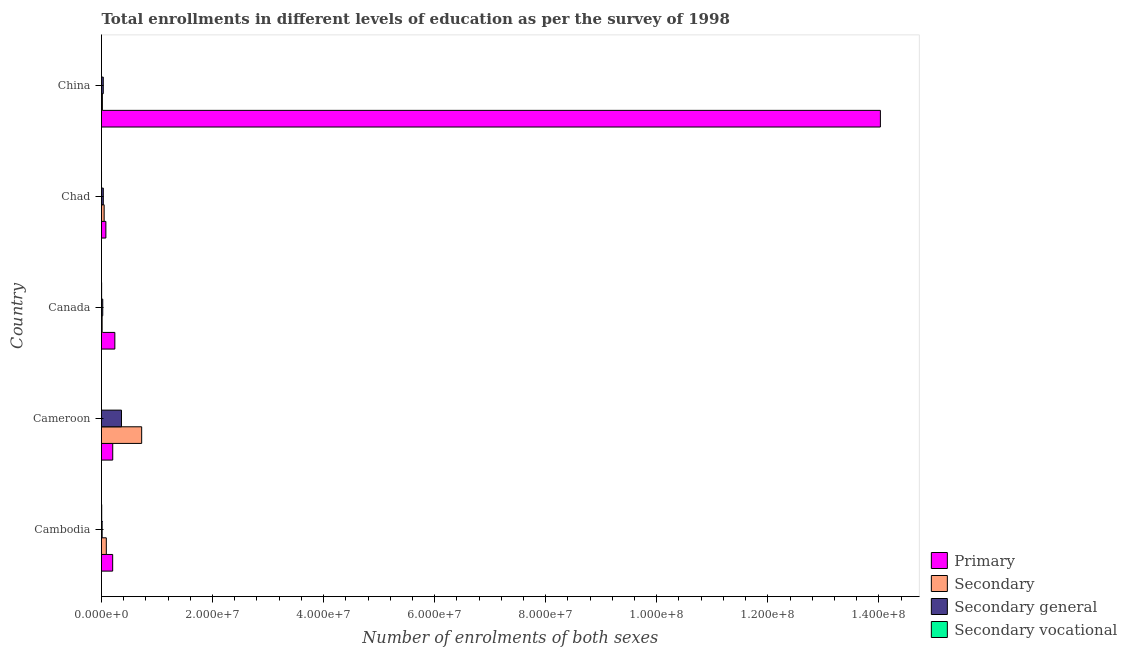How many bars are there on the 4th tick from the top?
Ensure brevity in your answer.  4. How many bars are there on the 5th tick from the bottom?
Offer a very short reply. 4. What is the number of enrolments in secondary vocational education in Cambodia?
Make the answer very short. 3.82e+04. Across all countries, what is the maximum number of enrolments in secondary general education?
Your answer should be compact. 3.60e+06. Across all countries, what is the minimum number of enrolments in secondary education?
Ensure brevity in your answer.  1.16e+05. In which country was the number of enrolments in secondary general education minimum?
Ensure brevity in your answer.  Cambodia. What is the total number of enrolments in secondary vocational education in the graph?
Keep it short and to the point. 6.26e+04. What is the difference between the number of enrolments in secondary general education in Cameroon and that in China?
Offer a very short reply. 3.28e+06. What is the difference between the number of enrolments in primary education in Chad and the number of enrolments in secondary general education in Cambodia?
Provide a succinct answer. 6.71e+05. What is the average number of enrolments in secondary vocational education per country?
Make the answer very short. 1.25e+04. What is the difference between the number of enrolments in primary education and number of enrolments in secondary general education in Canada?
Offer a terse response. 2.18e+06. In how many countries, is the number of enrolments in secondary vocational education greater than 104000000 ?
Offer a terse response. 0. What is the ratio of the number of enrolments in secondary general education in Cambodia to that in Chad?
Make the answer very short. 0.36. Is the difference between the number of enrolments in primary education in Canada and Chad greater than the difference between the number of enrolments in secondary vocational education in Canada and Chad?
Make the answer very short. Yes. What is the difference between the highest and the second highest number of enrolments in primary education?
Your answer should be very brief. 1.38e+08. What is the difference between the highest and the lowest number of enrolments in secondary general education?
Your answer should be compact. 3.48e+06. In how many countries, is the number of enrolments in secondary general education greater than the average number of enrolments in secondary general education taken over all countries?
Give a very brief answer. 1. What does the 4th bar from the top in Cambodia represents?
Keep it short and to the point. Primary. What does the 1st bar from the bottom in Canada represents?
Provide a succinct answer. Primary. Are the values on the major ticks of X-axis written in scientific E-notation?
Offer a terse response. Yes. Does the graph contain any zero values?
Your response must be concise. No. Where does the legend appear in the graph?
Provide a short and direct response. Bottom right. How many legend labels are there?
Ensure brevity in your answer.  4. What is the title of the graph?
Keep it short and to the point. Total enrollments in different levels of education as per the survey of 1998. What is the label or title of the X-axis?
Give a very brief answer. Number of enrolments of both sexes. What is the Number of enrolments of both sexes in Primary in Cambodia?
Provide a succinct answer. 2.01e+06. What is the Number of enrolments of both sexes in Secondary in Cambodia?
Make the answer very short. 8.67e+05. What is the Number of enrolments of both sexes in Secondary general in Cambodia?
Your response must be concise. 1.15e+05. What is the Number of enrolments of both sexes of Secondary vocational in Cambodia?
Keep it short and to the point. 3.82e+04. What is the Number of enrolments of both sexes in Primary in Cameroon?
Offer a terse response. 2.02e+06. What is the Number of enrolments of both sexes of Secondary in Cameroon?
Give a very brief answer. 7.23e+06. What is the Number of enrolments of both sexes in Secondary general in Cameroon?
Make the answer very short. 3.60e+06. What is the Number of enrolments of both sexes in Secondary vocational in Cameroon?
Make the answer very short. 655. What is the Number of enrolments of both sexes of Primary in Canada?
Give a very brief answer. 2.40e+06. What is the Number of enrolments of both sexes in Secondary in Canada?
Provide a short and direct response. 1.16e+05. What is the Number of enrolments of both sexes of Secondary general in Canada?
Keep it short and to the point. 2.23e+05. What is the Number of enrolments of both sexes of Secondary vocational in Canada?
Provide a short and direct response. 2.17e+04. What is the Number of enrolments of both sexes of Primary in Chad?
Keep it short and to the point. 7.87e+05. What is the Number of enrolments of both sexes of Secondary in Chad?
Keep it short and to the point. 4.78e+05. What is the Number of enrolments of both sexes in Secondary general in Chad?
Offer a terse response. 3.22e+05. What is the Number of enrolments of both sexes of Secondary vocational in Chad?
Offer a terse response. 1911. What is the Number of enrolments of both sexes in Primary in China?
Your answer should be very brief. 1.40e+08. What is the Number of enrolments of both sexes of Secondary in China?
Your answer should be compact. 1.60e+05. What is the Number of enrolments of both sexes of Secondary general in China?
Your response must be concise. 3.18e+05. What is the Number of enrolments of both sexes of Secondary vocational in China?
Ensure brevity in your answer.  90. Across all countries, what is the maximum Number of enrolments of both sexes of Primary?
Give a very brief answer. 1.40e+08. Across all countries, what is the maximum Number of enrolments of both sexes of Secondary?
Give a very brief answer. 7.23e+06. Across all countries, what is the maximum Number of enrolments of both sexes of Secondary general?
Your response must be concise. 3.60e+06. Across all countries, what is the maximum Number of enrolments of both sexes in Secondary vocational?
Ensure brevity in your answer.  3.82e+04. Across all countries, what is the minimum Number of enrolments of both sexes of Primary?
Make the answer very short. 7.87e+05. Across all countries, what is the minimum Number of enrolments of both sexes of Secondary?
Offer a terse response. 1.16e+05. Across all countries, what is the minimum Number of enrolments of both sexes in Secondary general?
Your answer should be very brief. 1.15e+05. What is the total Number of enrolments of both sexes of Primary in the graph?
Keep it short and to the point. 1.47e+08. What is the total Number of enrolments of both sexes in Secondary in the graph?
Your response must be concise. 8.85e+06. What is the total Number of enrolments of both sexes of Secondary general in the graph?
Keep it short and to the point. 4.58e+06. What is the total Number of enrolments of both sexes in Secondary vocational in the graph?
Give a very brief answer. 6.26e+04. What is the difference between the Number of enrolments of both sexes in Primary in Cambodia and that in Cameroon?
Offer a very short reply. -1.20e+04. What is the difference between the Number of enrolments of both sexes of Secondary in Cambodia and that in Cameroon?
Provide a succinct answer. -6.37e+06. What is the difference between the Number of enrolments of both sexes in Secondary general in Cambodia and that in Cameroon?
Make the answer very short. -3.48e+06. What is the difference between the Number of enrolments of both sexes in Secondary vocational in Cambodia and that in Cameroon?
Your response must be concise. 3.76e+04. What is the difference between the Number of enrolments of both sexes in Primary in Cambodia and that in Canada?
Ensure brevity in your answer.  -3.90e+05. What is the difference between the Number of enrolments of both sexes of Secondary in Cambodia and that in Canada?
Keep it short and to the point. 7.51e+05. What is the difference between the Number of enrolments of both sexes in Secondary general in Cambodia and that in Canada?
Provide a succinct answer. -1.08e+05. What is the difference between the Number of enrolments of both sexes in Secondary vocational in Cambodia and that in Canada?
Provide a succinct answer. 1.65e+04. What is the difference between the Number of enrolments of both sexes of Primary in Cambodia and that in Chad?
Make the answer very short. 1.23e+06. What is the difference between the Number of enrolments of both sexes of Secondary in Cambodia and that in Chad?
Give a very brief answer. 3.89e+05. What is the difference between the Number of enrolments of both sexes in Secondary general in Cambodia and that in Chad?
Your response must be concise. -2.07e+05. What is the difference between the Number of enrolments of both sexes in Secondary vocational in Cambodia and that in Chad?
Provide a short and direct response. 3.63e+04. What is the difference between the Number of enrolments of both sexes of Primary in Cambodia and that in China?
Ensure brevity in your answer.  -1.38e+08. What is the difference between the Number of enrolments of both sexes in Secondary in Cambodia and that in China?
Provide a succinct answer. 7.07e+05. What is the difference between the Number of enrolments of both sexes of Secondary general in Cambodia and that in China?
Provide a short and direct response. -2.03e+05. What is the difference between the Number of enrolments of both sexes in Secondary vocational in Cambodia and that in China?
Offer a terse response. 3.81e+04. What is the difference between the Number of enrolments of both sexes of Primary in Cameroon and that in Canada?
Offer a very short reply. -3.78e+05. What is the difference between the Number of enrolments of both sexes in Secondary in Cameroon and that in Canada?
Provide a succinct answer. 7.12e+06. What is the difference between the Number of enrolments of both sexes in Secondary general in Cameroon and that in Canada?
Provide a short and direct response. 3.37e+06. What is the difference between the Number of enrolments of both sexes of Secondary vocational in Cameroon and that in Canada?
Your answer should be very brief. -2.11e+04. What is the difference between the Number of enrolments of both sexes in Primary in Cameroon and that in Chad?
Your response must be concise. 1.24e+06. What is the difference between the Number of enrolments of both sexes of Secondary in Cameroon and that in Chad?
Your answer should be compact. 6.76e+06. What is the difference between the Number of enrolments of both sexes in Secondary general in Cameroon and that in Chad?
Give a very brief answer. 3.28e+06. What is the difference between the Number of enrolments of both sexes of Secondary vocational in Cameroon and that in Chad?
Offer a terse response. -1256. What is the difference between the Number of enrolments of both sexes in Primary in Cameroon and that in China?
Give a very brief answer. -1.38e+08. What is the difference between the Number of enrolments of both sexes of Secondary in Cameroon and that in China?
Provide a succinct answer. 7.07e+06. What is the difference between the Number of enrolments of both sexes of Secondary general in Cameroon and that in China?
Give a very brief answer. 3.28e+06. What is the difference between the Number of enrolments of both sexes in Secondary vocational in Cameroon and that in China?
Keep it short and to the point. 565. What is the difference between the Number of enrolments of both sexes in Primary in Canada and that in Chad?
Give a very brief answer. 1.62e+06. What is the difference between the Number of enrolments of both sexes of Secondary in Canada and that in Chad?
Offer a very short reply. -3.62e+05. What is the difference between the Number of enrolments of both sexes of Secondary general in Canada and that in Chad?
Your answer should be compact. -9.93e+04. What is the difference between the Number of enrolments of both sexes in Secondary vocational in Canada and that in Chad?
Your response must be concise. 1.98e+04. What is the difference between the Number of enrolments of both sexes in Primary in Canada and that in China?
Ensure brevity in your answer.  -1.38e+08. What is the difference between the Number of enrolments of both sexes of Secondary in Canada and that in China?
Offer a very short reply. -4.44e+04. What is the difference between the Number of enrolments of both sexes of Secondary general in Canada and that in China?
Offer a terse response. -9.53e+04. What is the difference between the Number of enrolments of both sexes of Secondary vocational in Canada and that in China?
Provide a succinct answer. 2.16e+04. What is the difference between the Number of enrolments of both sexes of Primary in Chad and that in China?
Your answer should be very brief. -1.39e+08. What is the difference between the Number of enrolments of both sexes of Secondary in Chad and that in China?
Offer a terse response. 3.18e+05. What is the difference between the Number of enrolments of both sexes in Secondary general in Chad and that in China?
Your answer should be compact. 4019. What is the difference between the Number of enrolments of both sexes of Secondary vocational in Chad and that in China?
Your answer should be very brief. 1821. What is the difference between the Number of enrolments of both sexes in Primary in Cambodia and the Number of enrolments of both sexes in Secondary in Cameroon?
Make the answer very short. -5.22e+06. What is the difference between the Number of enrolments of both sexes in Primary in Cambodia and the Number of enrolments of both sexes in Secondary general in Cameroon?
Ensure brevity in your answer.  -1.59e+06. What is the difference between the Number of enrolments of both sexes in Primary in Cambodia and the Number of enrolments of both sexes in Secondary vocational in Cameroon?
Your answer should be very brief. 2.01e+06. What is the difference between the Number of enrolments of both sexes of Secondary in Cambodia and the Number of enrolments of both sexes of Secondary general in Cameroon?
Keep it short and to the point. -2.73e+06. What is the difference between the Number of enrolments of both sexes of Secondary in Cambodia and the Number of enrolments of both sexes of Secondary vocational in Cameroon?
Provide a succinct answer. 8.66e+05. What is the difference between the Number of enrolments of both sexes of Secondary general in Cambodia and the Number of enrolments of both sexes of Secondary vocational in Cameroon?
Your response must be concise. 1.15e+05. What is the difference between the Number of enrolments of both sexes in Primary in Cambodia and the Number of enrolments of both sexes in Secondary in Canada?
Ensure brevity in your answer.  1.90e+06. What is the difference between the Number of enrolments of both sexes of Primary in Cambodia and the Number of enrolments of both sexes of Secondary general in Canada?
Provide a succinct answer. 1.79e+06. What is the difference between the Number of enrolments of both sexes in Primary in Cambodia and the Number of enrolments of both sexes in Secondary vocational in Canada?
Ensure brevity in your answer.  1.99e+06. What is the difference between the Number of enrolments of both sexes in Secondary in Cambodia and the Number of enrolments of both sexes in Secondary general in Canada?
Make the answer very short. 6.44e+05. What is the difference between the Number of enrolments of both sexes in Secondary in Cambodia and the Number of enrolments of both sexes in Secondary vocational in Canada?
Offer a very short reply. 8.45e+05. What is the difference between the Number of enrolments of both sexes in Secondary general in Cambodia and the Number of enrolments of both sexes in Secondary vocational in Canada?
Ensure brevity in your answer.  9.36e+04. What is the difference between the Number of enrolments of both sexes in Primary in Cambodia and the Number of enrolments of both sexes in Secondary in Chad?
Provide a succinct answer. 1.53e+06. What is the difference between the Number of enrolments of both sexes of Primary in Cambodia and the Number of enrolments of both sexes of Secondary general in Chad?
Your answer should be very brief. 1.69e+06. What is the difference between the Number of enrolments of both sexes of Primary in Cambodia and the Number of enrolments of both sexes of Secondary vocational in Chad?
Keep it short and to the point. 2.01e+06. What is the difference between the Number of enrolments of both sexes in Secondary in Cambodia and the Number of enrolments of both sexes in Secondary general in Chad?
Offer a terse response. 5.44e+05. What is the difference between the Number of enrolments of both sexes of Secondary in Cambodia and the Number of enrolments of both sexes of Secondary vocational in Chad?
Ensure brevity in your answer.  8.65e+05. What is the difference between the Number of enrolments of both sexes of Secondary general in Cambodia and the Number of enrolments of both sexes of Secondary vocational in Chad?
Give a very brief answer. 1.13e+05. What is the difference between the Number of enrolments of both sexes of Primary in Cambodia and the Number of enrolments of both sexes of Secondary in China?
Your answer should be compact. 1.85e+06. What is the difference between the Number of enrolments of both sexes of Primary in Cambodia and the Number of enrolments of both sexes of Secondary general in China?
Make the answer very short. 1.69e+06. What is the difference between the Number of enrolments of both sexes of Primary in Cambodia and the Number of enrolments of both sexes of Secondary vocational in China?
Keep it short and to the point. 2.01e+06. What is the difference between the Number of enrolments of both sexes of Secondary in Cambodia and the Number of enrolments of both sexes of Secondary general in China?
Offer a very short reply. 5.48e+05. What is the difference between the Number of enrolments of both sexes of Secondary in Cambodia and the Number of enrolments of both sexes of Secondary vocational in China?
Offer a very short reply. 8.67e+05. What is the difference between the Number of enrolments of both sexes of Secondary general in Cambodia and the Number of enrolments of both sexes of Secondary vocational in China?
Offer a very short reply. 1.15e+05. What is the difference between the Number of enrolments of both sexes in Primary in Cameroon and the Number of enrolments of both sexes in Secondary in Canada?
Your response must be concise. 1.91e+06. What is the difference between the Number of enrolments of both sexes in Primary in Cameroon and the Number of enrolments of both sexes in Secondary general in Canada?
Your answer should be very brief. 1.80e+06. What is the difference between the Number of enrolments of both sexes in Primary in Cameroon and the Number of enrolments of both sexes in Secondary vocational in Canada?
Your answer should be very brief. 2.00e+06. What is the difference between the Number of enrolments of both sexes in Secondary in Cameroon and the Number of enrolments of both sexes in Secondary general in Canada?
Make the answer very short. 7.01e+06. What is the difference between the Number of enrolments of both sexes of Secondary in Cameroon and the Number of enrolments of both sexes of Secondary vocational in Canada?
Make the answer very short. 7.21e+06. What is the difference between the Number of enrolments of both sexes of Secondary general in Cameroon and the Number of enrolments of both sexes of Secondary vocational in Canada?
Give a very brief answer. 3.58e+06. What is the difference between the Number of enrolments of both sexes of Primary in Cameroon and the Number of enrolments of both sexes of Secondary in Chad?
Your answer should be very brief. 1.55e+06. What is the difference between the Number of enrolments of both sexes of Primary in Cameroon and the Number of enrolments of both sexes of Secondary general in Chad?
Keep it short and to the point. 1.70e+06. What is the difference between the Number of enrolments of both sexes in Primary in Cameroon and the Number of enrolments of both sexes in Secondary vocational in Chad?
Your answer should be very brief. 2.02e+06. What is the difference between the Number of enrolments of both sexes of Secondary in Cameroon and the Number of enrolments of both sexes of Secondary general in Chad?
Provide a succinct answer. 6.91e+06. What is the difference between the Number of enrolments of both sexes in Secondary in Cameroon and the Number of enrolments of both sexes in Secondary vocational in Chad?
Give a very brief answer. 7.23e+06. What is the difference between the Number of enrolments of both sexes of Secondary general in Cameroon and the Number of enrolments of both sexes of Secondary vocational in Chad?
Offer a very short reply. 3.60e+06. What is the difference between the Number of enrolments of both sexes of Primary in Cameroon and the Number of enrolments of both sexes of Secondary in China?
Your response must be concise. 1.86e+06. What is the difference between the Number of enrolments of both sexes in Primary in Cameroon and the Number of enrolments of both sexes in Secondary general in China?
Make the answer very short. 1.71e+06. What is the difference between the Number of enrolments of both sexes of Primary in Cameroon and the Number of enrolments of both sexes of Secondary vocational in China?
Ensure brevity in your answer.  2.02e+06. What is the difference between the Number of enrolments of both sexes of Secondary in Cameroon and the Number of enrolments of both sexes of Secondary general in China?
Your answer should be compact. 6.91e+06. What is the difference between the Number of enrolments of both sexes in Secondary in Cameroon and the Number of enrolments of both sexes in Secondary vocational in China?
Your answer should be compact. 7.23e+06. What is the difference between the Number of enrolments of both sexes in Secondary general in Cameroon and the Number of enrolments of both sexes in Secondary vocational in China?
Provide a short and direct response. 3.60e+06. What is the difference between the Number of enrolments of both sexes in Primary in Canada and the Number of enrolments of both sexes in Secondary in Chad?
Your answer should be very brief. 1.92e+06. What is the difference between the Number of enrolments of both sexes of Primary in Canada and the Number of enrolments of both sexes of Secondary general in Chad?
Make the answer very short. 2.08e+06. What is the difference between the Number of enrolments of both sexes in Primary in Canada and the Number of enrolments of both sexes in Secondary vocational in Chad?
Offer a terse response. 2.40e+06. What is the difference between the Number of enrolments of both sexes of Secondary in Canada and the Number of enrolments of both sexes of Secondary general in Chad?
Make the answer very short. -2.07e+05. What is the difference between the Number of enrolments of both sexes of Secondary in Canada and the Number of enrolments of both sexes of Secondary vocational in Chad?
Your answer should be compact. 1.14e+05. What is the difference between the Number of enrolments of both sexes in Secondary general in Canada and the Number of enrolments of both sexes in Secondary vocational in Chad?
Keep it short and to the point. 2.21e+05. What is the difference between the Number of enrolments of both sexes in Primary in Canada and the Number of enrolments of both sexes in Secondary in China?
Ensure brevity in your answer.  2.24e+06. What is the difference between the Number of enrolments of both sexes of Primary in Canada and the Number of enrolments of both sexes of Secondary general in China?
Your answer should be compact. 2.08e+06. What is the difference between the Number of enrolments of both sexes in Primary in Canada and the Number of enrolments of both sexes in Secondary vocational in China?
Give a very brief answer. 2.40e+06. What is the difference between the Number of enrolments of both sexes in Secondary in Canada and the Number of enrolments of both sexes in Secondary general in China?
Your answer should be compact. -2.03e+05. What is the difference between the Number of enrolments of both sexes in Secondary in Canada and the Number of enrolments of both sexes in Secondary vocational in China?
Offer a very short reply. 1.16e+05. What is the difference between the Number of enrolments of both sexes in Secondary general in Canada and the Number of enrolments of both sexes in Secondary vocational in China?
Ensure brevity in your answer.  2.23e+05. What is the difference between the Number of enrolments of both sexes in Primary in Chad and the Number of enrolments of both sexes in Secondary in China?
Keep it short and to the point. 6.26e+05. What is the difference between the Number of enrolments of both sexes in Primary in Chad and the Number of enrolments of both sexes in Secondary general in China?
Give a very brief answer. 4.68e+05. What is the difference between the Number of enrolments of both sexes in Primary in Chad and the Number of enrolments of both sexes in Secondary vocational in China?
Ensure brevity in your answer.  7.86e+05. What is the difference between the Number of enrolments of both sexes in Secondary in Chad and the Number of enrolments of both sexes in Secondary general in China?
Give a very brief answer. 1.60e+05. What is the difference between the Number of enrolments of both sexes of Secondary in Chad and the Number of enrolments of both sexes of Secondary vocational in China?
Provide a short and direct response. 4.78e+05. What is the difference between the Number of enrolments of both sexes of Secondary general in Chad and the Number of enrolments of both sexes of Secondary vocational in China?
Provide a short and direct response. 3.22e+05. What is the average Number of enrolments of both sexes of Primary per country?
Your answer should be very brief. 2.95e+07. What is the average Number of enrolments of both sexes of Secondary per country?
Your response must be concise. 1.77e+06. What is the average Number of enrolments of both sexes in Secondary general per country?
Give a very brief answer. 9.15e+05. What is the average Number of enrolments of both sexes of Secondary vocational per country?
Your answer should be very brief. 1.25e+04. What is the difference between the Number of enrolments of both sexes of Primary and Number of enrolments of both sexes of Secondary in Cambodia?
Your answer should be very brief. 1.15e+06. What is the difference between the Number of enrolments of both sexes of Primary and Number of enrolments of both sexes of Secondary general in Cambodia?
Your answer should be very brief. 1.90e+06. What is the difference between the Number of enrolments of both sexes in Primary and Number of enrolments of both sexes in Secondary vocational in Cambodia?
Your answer should be very brief. 1.97e+06. What is the difference between the Number of enrolments of both sexes of Secondary and Number of enrolments of both sexes of Secondary general in Cambodia?
Ensure brevity in your answer.  7.51e+05. What is the difference between the Number of enrolments of both sexes of Secondary and Number of enrolments of both sexes of Secondary vocational in Cambodia?
Your answer should be very brief. 8.28e+05. What is the difference between the Number of enrolments of both sexes in Secondary general and Number of enrolments of both sexes in Secondary vocational in Cambodia?
Ensure brevity in your answer.  7.71e+04. What is the difference between the Number of enrolments of both sexes of Primary and Number of enrolments of both sexes of Secondary in Cameroon?
Give a very brief answer. -5.21e+06. What is the difference between the Number of enrolments of both sexes in Primary and Number of enrolments of both sexes in Secondary general in Cameroon?
Your answer should be compact. -1.57e+06. What is the difference between the Number of enrolments of both sexes of Primary and Number of enrolments of both sexes of Secondary vocational in Cameroon?
Offer a terse response. 2.02e+06. What is the difference between the Number of enrolments of both sexes in Secondary and Number of enrolments of both sexes in Secondary general in Cameroon?
Offer a terse response. 3.64e+06. What is the difference between the Number of enrolments of both sexes of Secondary and Number of enrolments of both sexes of Secondary vocational in Cameroon?
Make the answer very short. 7.23e+06. What is the difference between the Number of enrolments of both sexes of Secondary general and Number of enrolments of both sexes of Secondary vocational in Cameroon?
Offer a terse response. 3.60e+06. What is the difference between the Number of enrolments of both sexes of Primary and Number of enrolments of both sexes of Secondary in Canada?
Give a very brief answer. 2.29e+06. What is the difference between the Number of enrolments of both sexes of Primary and Number of enrolments of both sexes of Secondary general in Canada?
Offer a terse response. 2.18e+06. What is the difference between the Number of enrolments of both sexes in Primary and Number of enrolments of both sexes in Secondary vocational in Canada?
Your answer should be very brief. 2.38e+06. What is the difference between the Number of enrolments of both sexes in Secondary and Number of enrolments of both sexes in Secondary general in Canada?
Ensure brevity in your answer.  -1.07e+05. What is the difference between the Number of enrolments of both sexes in Secondary and Number of enrolments of both sexes in Secondary vocational in Canada?
Your answer should be compact. 9.39e+04. What is the difference between the Number of enrolments of both sexes of Secondary general and Number of enrolments of both sexes of Secondary vocational in Canada?
Give a very brief answer. 2.01e+05. What is the difference between the Number of enrolments of both sexes of Primary and Number of enrolments of both sexes of Secondary in Chad?
Offer a very short reply. 3.09e+05. What is the difference between the Number of enrolments of both sexes of Primary and Number of enrolments of both sexes of Secondary general in Chad?
Offer a very short reply. 4.64e+05. What is the difference between the Number of enrolments of both sexes of Primary and Number of enrolments of both sexes of Secondary vocational in Chad?
Your answer should be compact. 7.85e+05. What is the difference between the Number of enrolments of both sexes in Secondary and Number of enrolments of both sexes in Secondary general in Chad?
Give a very brief answer. 1.56e+05. What is the difference between the Number of enrolments of both sexes in Secondary and Number of enrolments of both sexes in Secondary vocational in Chad?
Give a very brief answer. 4.76e+05. What is the difference between the Number of enrolments of both sexes in Secondary general and Number of enrolments of both sexes in Secondary vocational in Chad?
Give a very brief answer. 3.20e+05. What is the difference between the Number of enrolments of both sexes in Primary and Number of enrolments of both sexes in Secondary in China?
Offer a very short reply. 1.40e+08. What is the difference between the Number of enrolments of both sexes in Primary and Number of enrolments of both sexes in Secondary general in China?
Your response must be concise. 1.40e+08. What is the difference between the Number of enrolments of both sexes of Primary and Number of enrolments of both sexes of Secondary vocational in China?
Your response must be concise. 1.40e+08. What is the difference between the Number of enrolments of both sexes of Secondary and Number of enrolments of both sexes of Secondary general in China?
Provide a succinct answer. -1.58e+05. What is the difference between the Number of enrolments of both sexes of Secondary and Number of enrolments of both sexes of Secondary vocational in China?
Make the answer very short. 1.60e+05. What is the difference between the Number of enrolments of both sexes in Secondary general and Number of enrolments of both sexes in Secondary vocational in China?
Your answer should be compact. 3.18e+05. What is the ratio of the Number of enrolments of both sexes in Primary in Cambodia to that in Cameroon?
Make the answer very short. 0.99. What is the ratio of the Number of enrolments of both sexes of Secondary in Cambodia to that in Cameroon?
Provide a short and direct response. 0.12. What is the ratio of the Number of enrolments of both sexes in Secondary general in Cambodia to that in Cameroon?
Offer a very short reply. 0.03. What is the ratio of the Number of enrolments of both sexes of Secondary vocational in Cambodia to that in Cameroon?
Provide a succinct answer. 58.38. What is the ratio of the Number of enrolments of both sexes in Primary in Cambodia to that in Canada?
Ensure brevity in your answer.  0.84. What is the ratio of the Number of enrolments of both sexes of Secondary in Cambodia to that in Canada?
Your response must be concise. 7.5. What is the ratio of the Number of enrolments of both sexes in Secondary general in Cambodia to that in Canada?
Give a very brief answer. 0.52. What is the ratio of the Number of enrolments of both sexes of Secondary vocational in Cambodia to that in Canada?
Offer a very short reply. 1.76. What is the ratio of the Number of enrolments of both sexes in Primary in Cambodia to that in Chad?
Provide a short and direct response. 2.56. What is the ratio of the Number of enrolments of both sexes in Secondary in Cambodia to that in Chad?
Offer a terse response. 1.81. What is the ratio of the Number of enrolments of both sexes of Secondary general in Cambodia to that in Chad?
Provide a succinct answer. 0.36. What is the ratio of the Number of enrolments of both sexes of Secondary vocational in Cambodia to that in Chad?
Ensure brevity in your answer.  20.01. What is the ratio of the Number of enrolments of both sexes in Primary in Cambodia to that in China?
Keep it short and to the point. 0.01. What is the ratio of the Number of enrolments of both sexes of Secondary in Cambodia to that in China?
Provide a short and direct response. 5.41. What is the ratio of the Number of enrolments of both sexes in Secondary general in Cambodia to that in China?
Offer a very short reply. 0.36. What is the ratio of the Number of enrolments of both sexes in Secondary vocational in Cambodia to that in China?
Your answer should be very brief. 424.86. What is the ratio of the Number of enrolments of both sexes in Primary in Cameroon to that in Canada?
Your response must be concise. 0.84. What is the ratio of the Number of enrolments of both sexes of Secondary in Cameroon to that in Canada?
Your response must be concise. 62.56. What is the ratio of the Number of enrolments of both sexes of Secondary general in Cameroon to that in Canada?
Your answer should be very brief. 16.13. What is the ratio of the Number of enrolments of both sexes in Secondary vocational in Cameroon to that in Canada?
Your answer should be compact. 0.03. What is the ratio of the Number of enrolments of both sexes of Primary in Cameroon to that in Chad?
Your response must be concise. 2.57. What is the ratio of the Number of enrolments of both sexes in Secondary in Cameroon to that in Chad?
Offer a terse response. 15.13. What is the ratio of the Number of enrolments of both sexes in Secondary general in Cameroon to that in Chad?
Ensure brevity in your answer.  11.16. What is the ratio of the Number of enrolments of both sexes of Secondary vocational in Cameroon to that in Chad?
Provide a short and direct response. 0.34. What is the ratio of the Number of enrolments of both sexes of Primary in Cameroon to that in China?
Provide a succinct answer. 0.01. What is the ratio of the Number of enrolments of both sexes of Secondary in Cameroon to that in China?
Make the answer very short. 45.19. What is the ratio of the Number of enrolments of both sexes in Secondary general in Cameroon to that in China?
Your answer should be compact. 11.3. What is the ratio of the Number of enrolments of both sexes in Secondary vocational in Cameroon to that in China?
Keep it short and to the point. 7.28. What is the ratio of the Number of enrolments of both sexes in Primary in Canada to that in Chad?
Give a very brief answer. 3.05. What is the ratio of the Number of enrolments of both sexes in Secondary in Canada to that in Chad?
Your response must be concise. 0.24. What is the ratio of the Number of enrolments of both sexes in Secondary general in Canada to that in Chad?
Provide a short and direct response. 0.69. What is the ratio of the Number of enrolments of both sexes of Secondary vocational in Canada to that in Chad?
Offer a very short reply. 11.37. What is the ratio of the Number of enrolments of both sexes of Primary in Canada to that in China?
Offer a very short reply. 0.02. What is the ratio of the Number of enrolments of both sexes of Secondary in Canada to that in China?
Keep it short and to the point. 0.72. What is the ratio of the Number of enrolments of both sexes of Secondary general in Canada to that in China?
Ensure brevity in your answer.  0.7. What is the ratio of the Number of enrolments of both sexes in Secondary vocational in Canada to that in China?
Provide a succinct answer. 241.52. What is the ratio of the Number of enrolments of both sexes in Primary in Chad to that in China?
Make the answer very short. 0.01. What is the ratio of the Number of enrolments of both sexes in Secondary in Chad to that in China?
Provide a short and direct response. 2.99. What is the ratio of the Number of enrolments of both sexes in Secondary general in Chad to that in China?
Your answer should be very brief. 1.01. What is the ratio of the Number of enrolments of both sexes of Secondary vocational in Chad to that in China?
Provide a short and direct response. 21.23. What is the difference between the highest and the second highest Number of enrolments of both sexes in Primary?
Your answer should be very brief. 1.38e+08. What is the difference between the highest and the second highest Number of enrolments of both sexes in Secondary?
Your answer should be very brief. 6.37e+06. What is the difference between the highest and the second highest Number of enrolments of both sexes in Secondary general?
Keep it short and to the point. 3.28e+06. What is the difference between the highest and the second highest Number of enrolments of both sexes of Secondary vocational?
Provide a short and direct response. 1.65e+04. What is the difference between the highest and the lowest Number of enrolments of both sexes of Primary?
Your response must be concise. 1.39e+08. What is the difference between the highest and the lowest Number of enrolments of both sexes of Secondary?
Make the answer very short. 7.12e+06. What is the difference between the highest and the lowest Number of enrolments of both sexes of Secondary general?
Ensure brevity in your answer.  3.48e+06. What is the difference between the highest and the lowest Number of enrolments of both sexes in Secondary vocational?
Offer a terse response. 3.81e+04. 